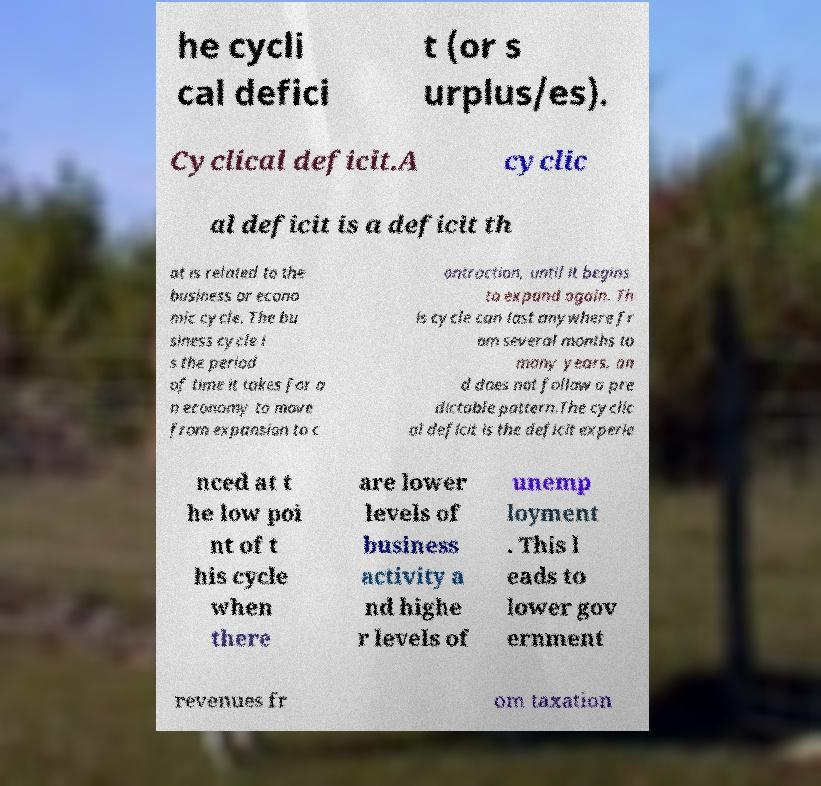I need the written content from this picture converted into text. Can you do that? he cycli cal defici t (or s urplus/es). Cyclical deficit.A cyclic al deficit is a deficit th at is related to the business or econo mic cycle. The bu siness cycle i s the period of time it takes for a n economy to move from expansion to c ontraction, until it begins to expand again. Th is cycle can last anywhere fr om several months to many years, an d does not follow a pre dictable pattern.The cyclic al deficit is the deficit experie nced at t he low poi nt of t his cycle when there are lower levels of business activity a nd highe r levels of unemp loyment . This l eads to lower gov ernment revenues fr om taxation 